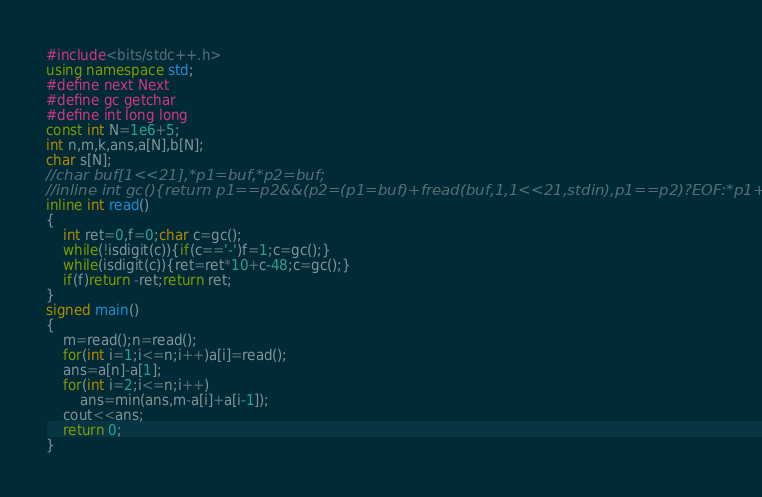Convert code to text. <code><loc_0><loc_0><loc_500><loc_500><_C++_>#include<bits/stdc++.h>
using namespace std;
#define next Next
#define gc getchar
#define int long long
const int N=1e6+5;
int n,m,k,ans,a[N],b[N];
char s[N];
//char buf[1<<21],*p1=buf,*p2=buf;
//inline int gc(){return p1==p2&&(p2=(p1=buf)+fread(buf,1,1<<21,stdin),p1==p2)?EOF:*p1++;}
inline int read()
{
    int ret=0,f=0;char c=gc();
    while(!isdigit(c)){if(c=='-')f=1;c=gc();}
    while(isdigit(c)){ret=ret*10+c-48;c=gc();}
    if(f)return -ret;return ret;
}
signed main()
{
	m=read();n=read();
	for(int i=1;i<=n;i++)a[i]=read();
	ans=a[n]-a[1];
	for(int i=2;i<=n;i++)
		ans=min(ans,m-a[i]+a[i-1]);
	cout<<ans;
	return 0;
}</code> 